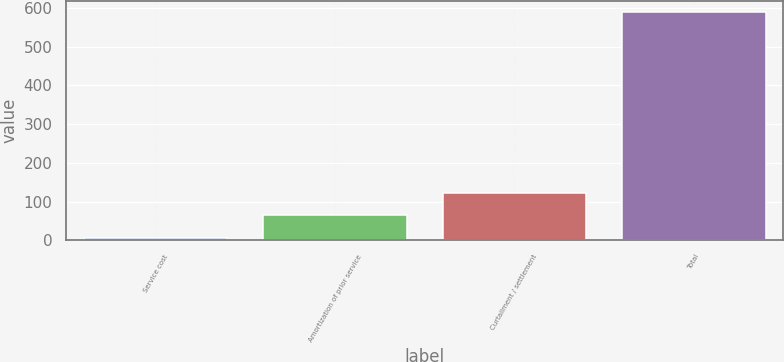Convert chart. <chart><loc_0><loc_0><loc_500><loc_500><bar_chart><fcel>Service cost<fcel>Amortization of prior service<fcel>Curtailment / settlement<fcel>Total<nl><fcel>7<fcel>65.2<fcel>123.4<fcel>589<nl></chart> 